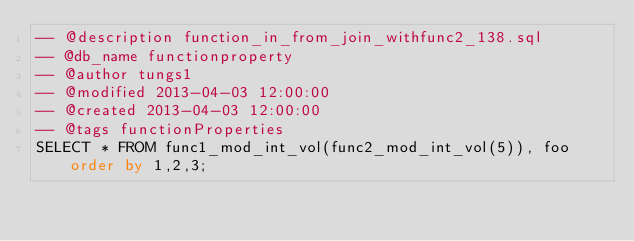<code> <loc_0><loc_0><loc_500><loc_500><_SQL_>-- @description function_in_from_join_withfunc2_138.sql
-- @db_name functionproperty
-- @author tungs1
-- @modified 2013-04-03 12:00:00
-- @created 2013-04-03 12:00:00
-- @tags functionProperties 
SELECT * FROM func1_mod_int_vol(func2_mod_int_vol(5)), foo order by 1,2,3; 
</code> 